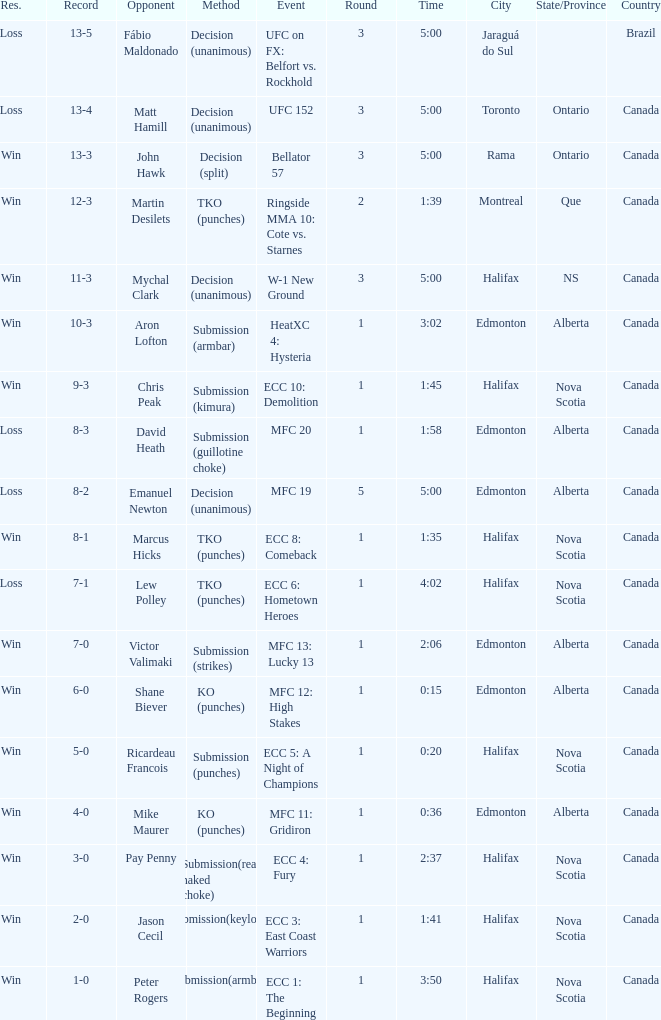What is the round of the match with Emanuel Newton as the opponent? 5.0. 